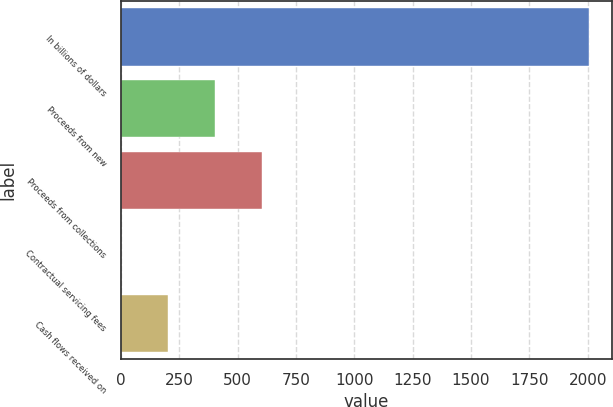Convert chart. <chart><loc_0><loc_0><loc_500><loc_500><bar_chart><fcel>In billions of dollars<fcel>Proceeds from new<fcel>Proceeds from collections<fcel>Contractual servicing fees<fcel>Cash flows received on<nl><fcel>2006<fcel>402.88<fcel>603.27<fcel>2.1<fcel>202.49<nl></chart> 